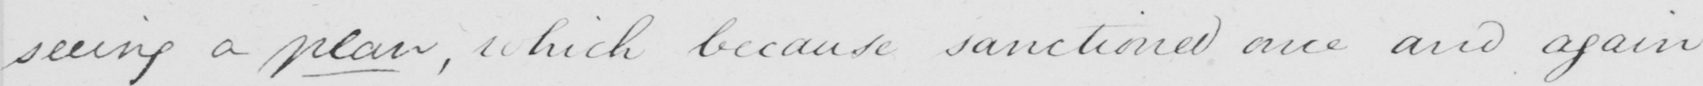Please provide the text content of this handwritten line. seeing a plan , which because sanctioned and again 